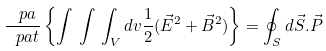Convert formula to latex. <formula><loc_0><loc_0><loc_500><loc_500>\frac { \ p a } { \ p a t } \left \{ \int \, \int \, \int _ { V } d { v } \frac { 1 } 2 ( \vec { E } ^ { 2 } + \vec { B } ^ { 2 } ) \right \} = \oint _ { S } d \vec { S } . \vec { P }</formula> 